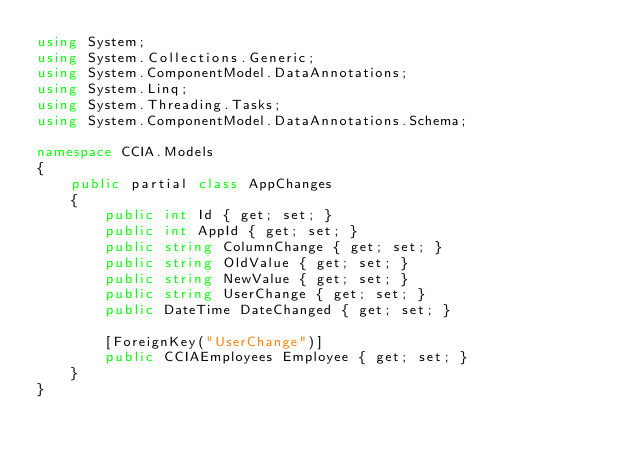Convert code to text. <code><loc_0><loc_0><loc_500><loc_500><_C#_>using System;
using System.Collections.Generic;
using System.ComponentModel.DataAnnotations;
using System.Linq;
using System.Threading.Tasks;
using System.ComponentModel.DataAnnotations.Schema;

namespace CCIA.Models
{
    public partial class AppChanges
    { 
        public int Id { get; set; }       
        public int AppId { get; set; }
        public string ColumnChange { get; set; }
        public string OldValue { get; set; }
        public string NewValue { get; set; }
        public string UserChange { get; set; }
        public DateTime DateChanged { get; set; }

        [ForeignKey("UserChange")]
        public CCIAEmployees Employee { get; set; }
    }
}</code> 